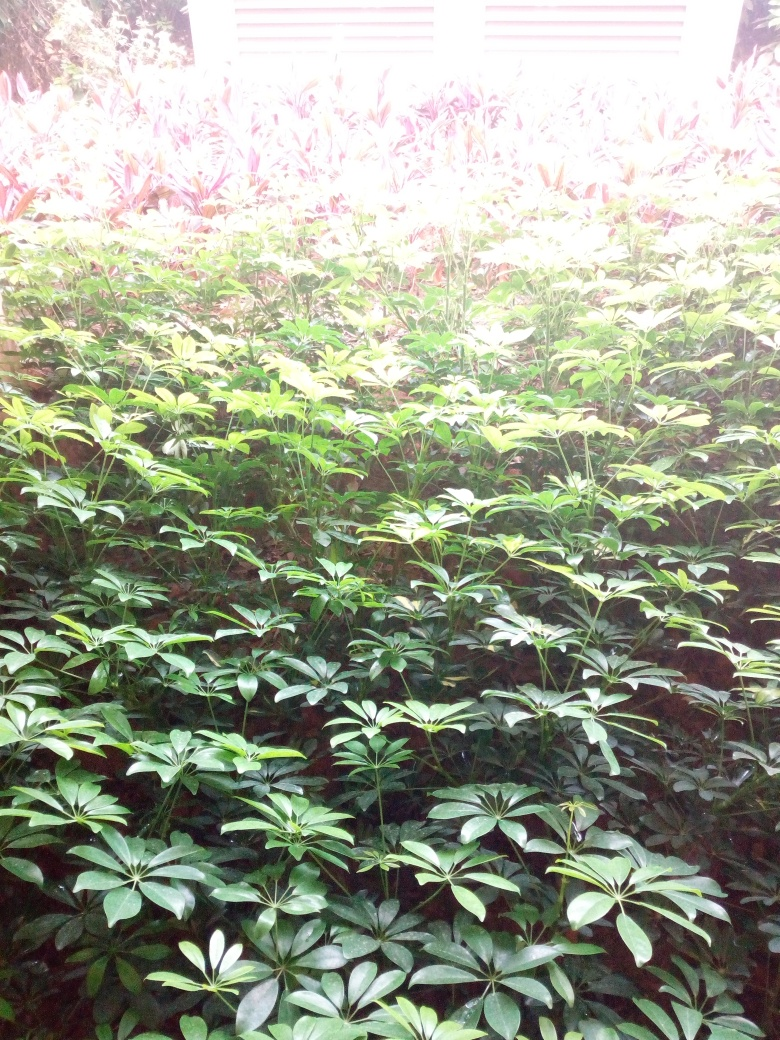Could this be an image from a tropical location? The dense foliage and diversity of plants with broad leaves hint at a tropical or subtropical environment. Such climates enable a wide variety of plant species to thrive. Without more context or geographical indicators, it's a plausible assumption, though not definitive. 